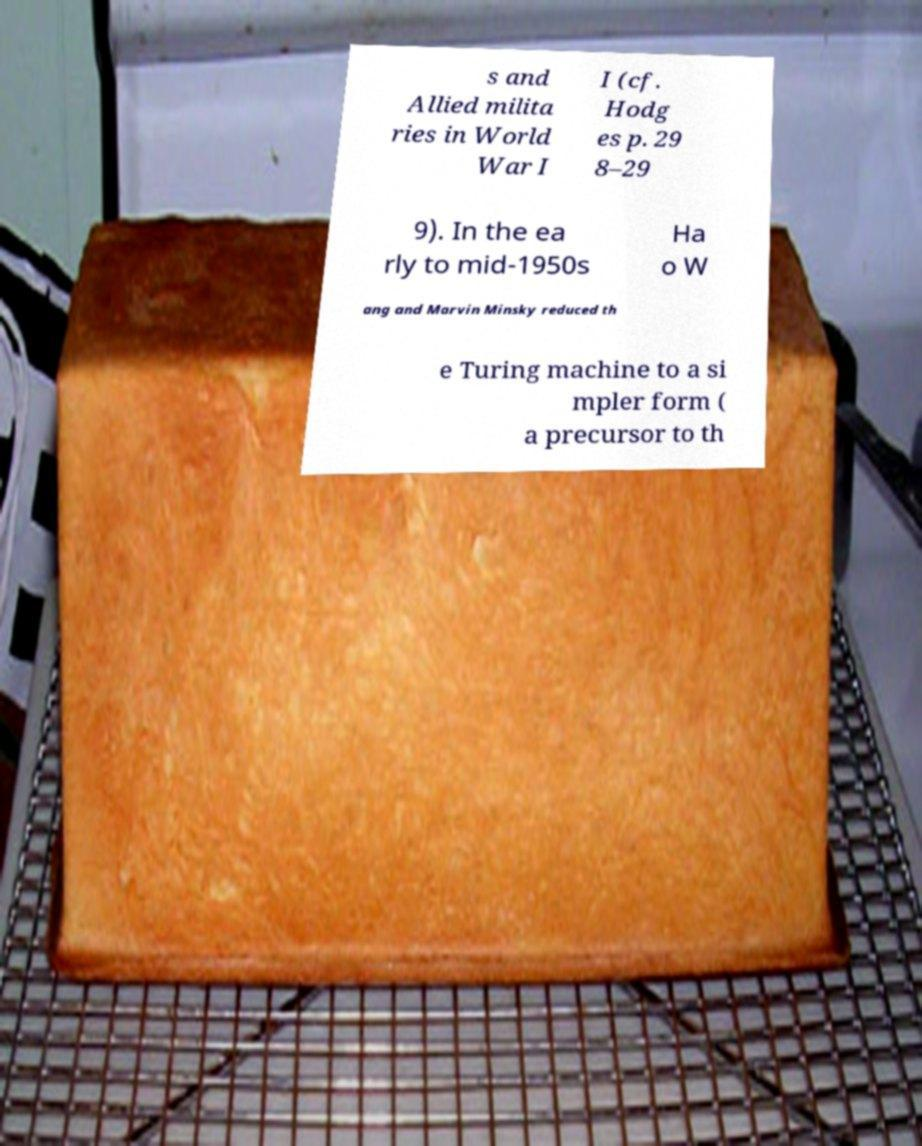Can you accurately transcribe the text from the provided image for me? s and Allied milita ries in World War I I (cf. Hodg es p. 29 8–29 9). In the ea rly to mid-1950s Ha o W ang and Marvin Minsky reduced th e Turing machine to a si mpler form ( a precursor to th 